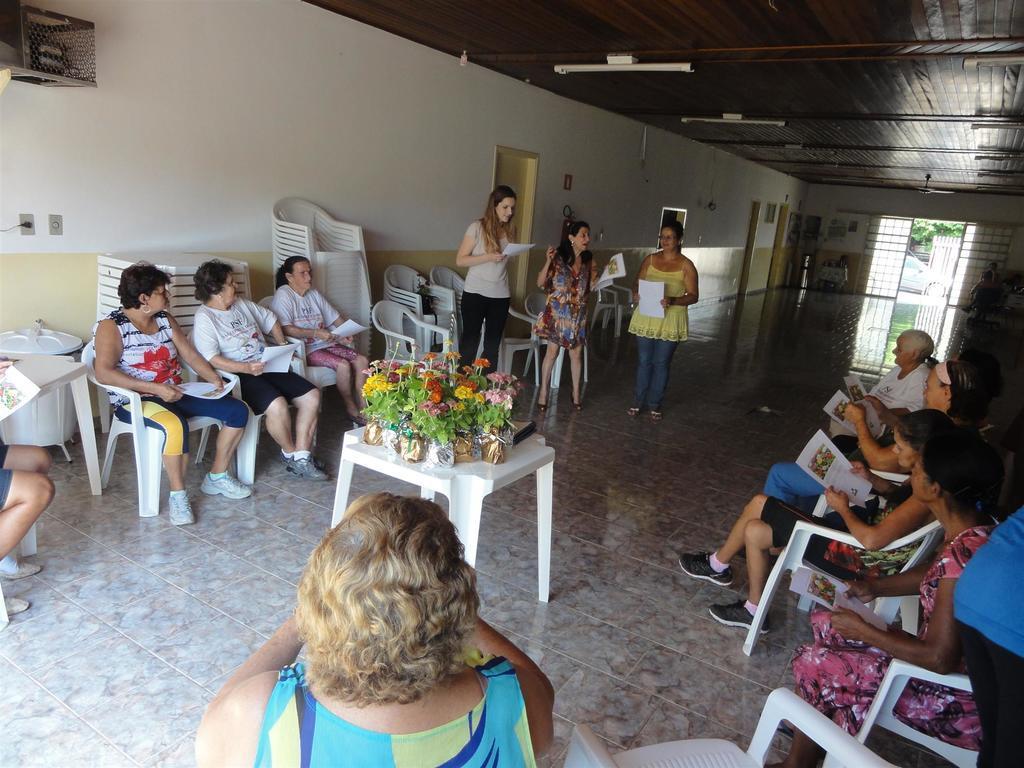Can you describe this image briefly? In this image there are group of people sitting and standing reading out the papers and at the middle of the image there are flowers and at the right side of the image there is a door. 